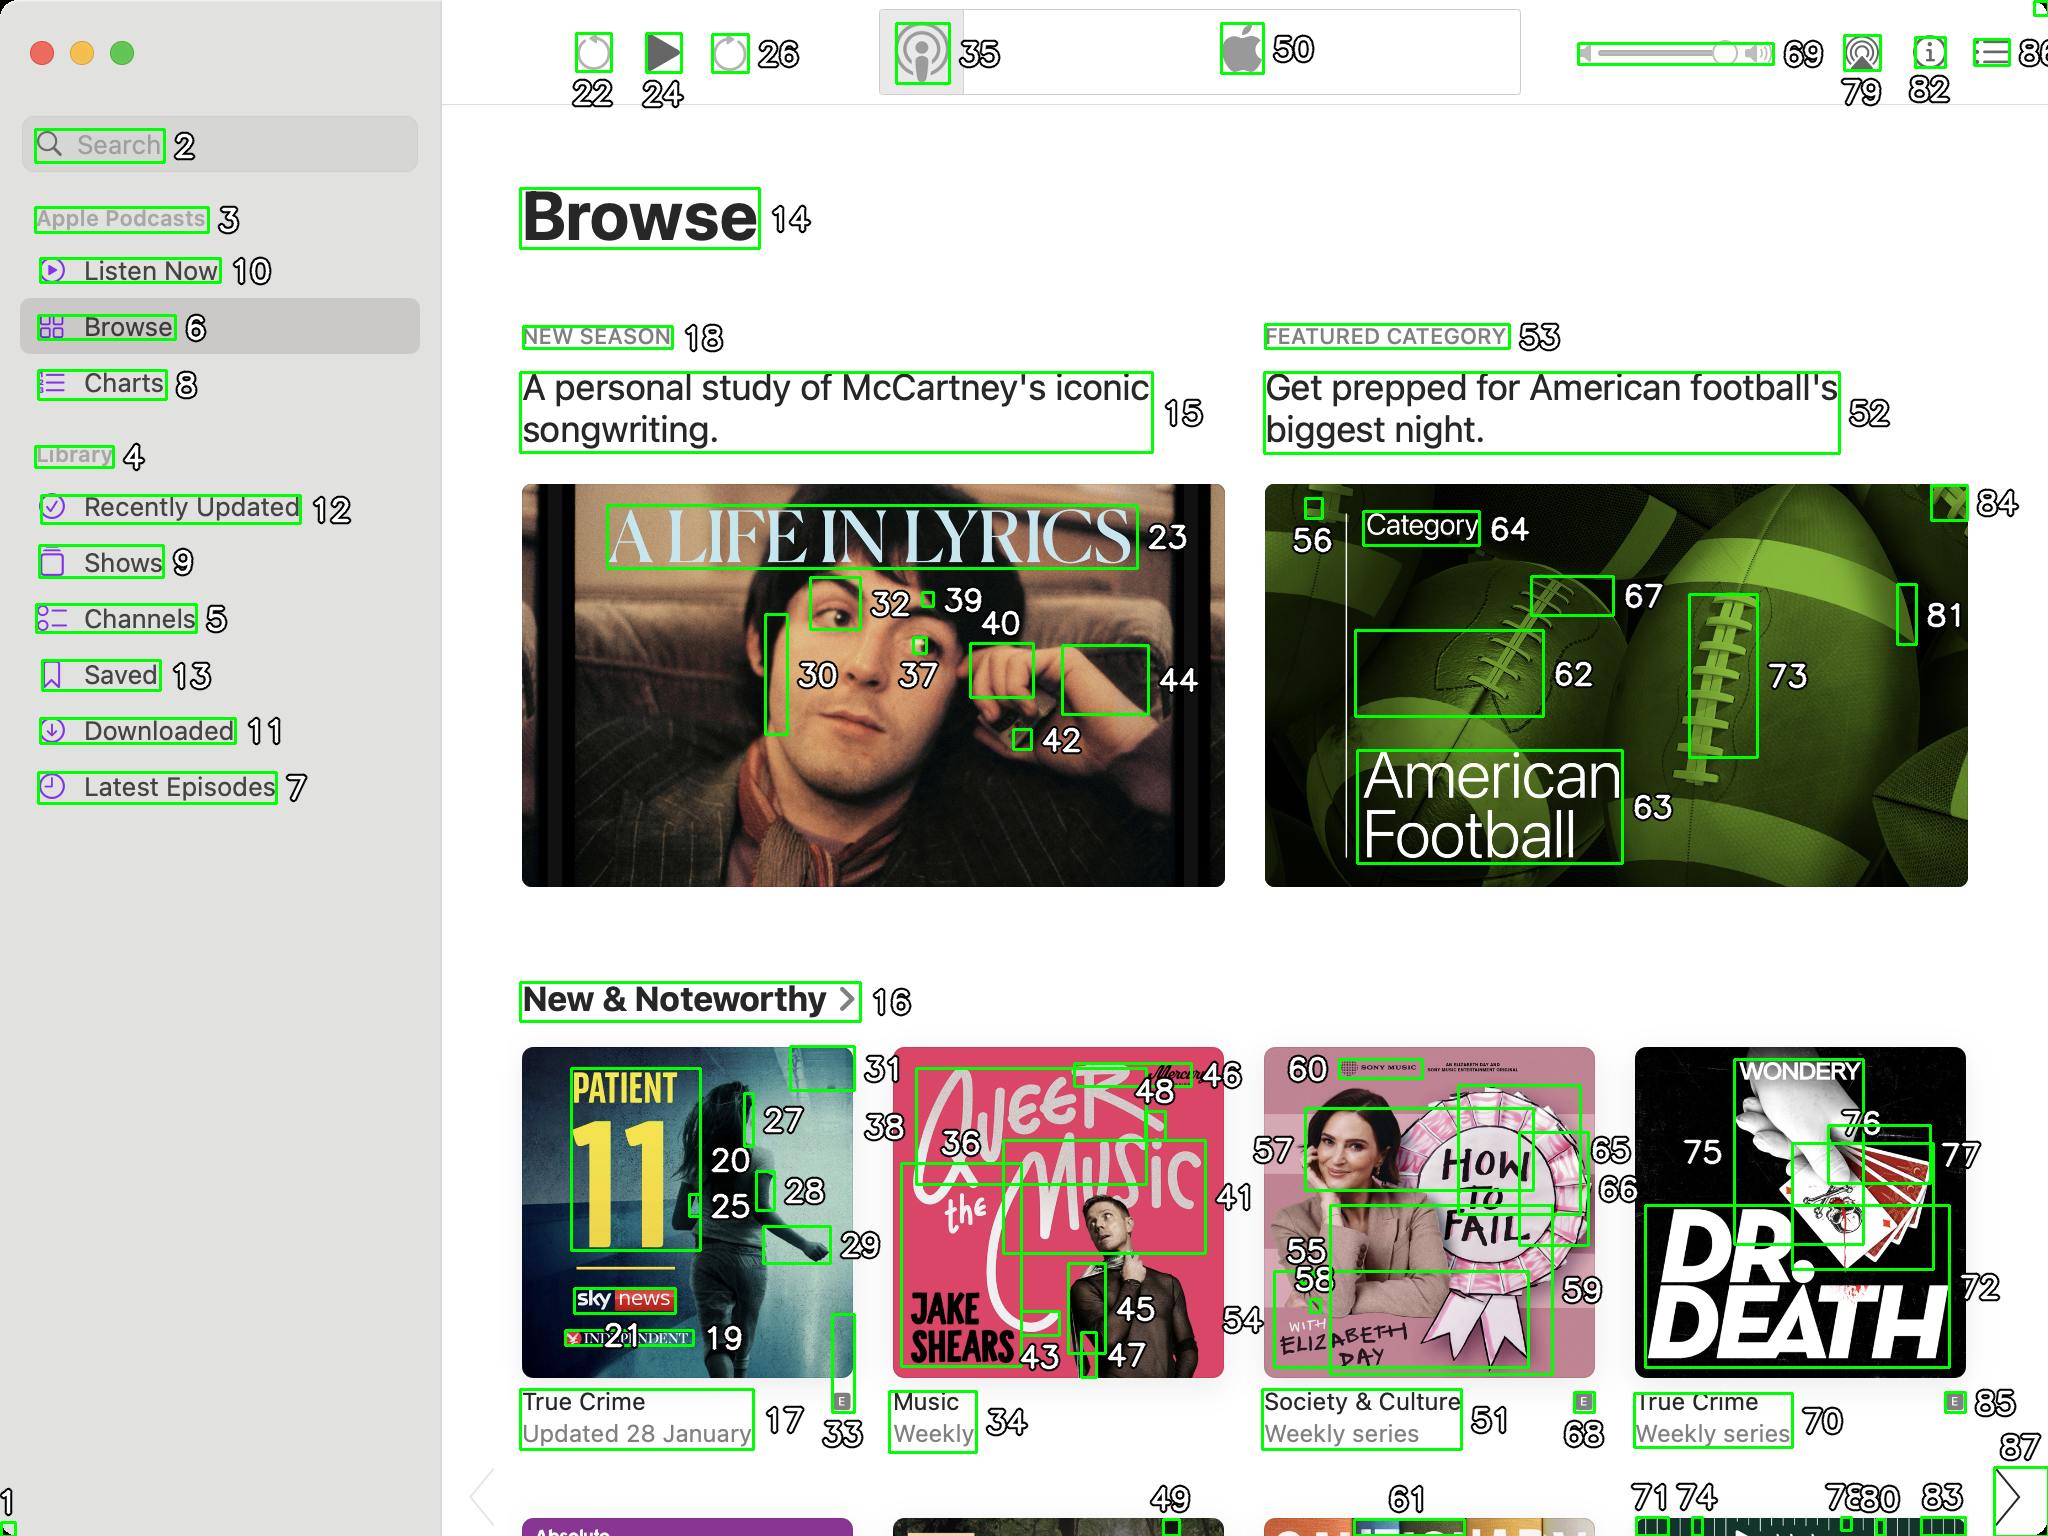You are an AI designed for image processing and segmentation analysis, particularly skilled in merging segmented regions of an image to improve accuracy and readability.

**Task Description:**
Your task is to address a user's concern with a UI screenshot of the Apple Podcasts application on MacOS. The screenshot contains multiple green boxes, each representing a UI element, with a unique white number outlined in black ranging from 1 to 88. Due to segmentation issues, some boxes that belong to the same image are divided unnaturally.

**Objective:**
Merge these segmented areas that correspond to a single UI element to create a coherent representation. The final output should be in JSON format, where each key-value pair represents the merged areas.

**Example JSON Output:**
If boxes with numbers 1, 2, and 3 should belong to the same UI element, the JSON output should be:

```json
{
    "Image A Life In Lyrics": [1, 2, 3]
}
```

**Instructions:**

- **Identify Segmented Regions:** Analyze the screenshot to identify which green boxes belong to the same UI element.
- **Merge Regions:** Group the numbers of these boxes together to represent a single UI element.
- **Output Format:** Produce the output in JSON format, with each key representing a UI element and each value being a list of the numbers of the merged boxes. Don't include in the result UI elements that consist of one box.

**Primary Objective:**
Ensure the accuracy of the merged regions based on the user's supplied image information, maintaining the integrity and structure of the UI elements in the Apple Podcasts application on MacOS. ```json
{
    "Search": [2],
    "Apple Podcasts": [3],
    "Listen Now": [10],
    "Browse": [6],
    "Charts": [8],
    "Library": [4],
    "Recently Updated": [12],
    "Shows": [9],
    "Channels": [5],
    "Saved": [13],
    "Downloaded": [11],
    "Latest Episodes": [7],
    "Browse Header": [14],
    "New Season": [18],
    "A Life In Lyrics": [23, 30, 32, 37, 39, 40, 42, 44],
    "Featured Category": [53],
    "American Football": [52, 62, 63, 64, 67, 73, 81],
    "New & Noteworthy": [16],
    "Patient 11": [17, 19, 20, 21, 25, 28, 31, 33],
    "Jake Shears": [34, 35, 36, 38, 43, 45, 46, 48],
    "How To Fail": [51, 55, 56, 57, 58, 59, 60],
    "Dr. Death": [68, 70, 71, 72, 74, 75, 76, 77, 78, 80, 85]
}
``` 